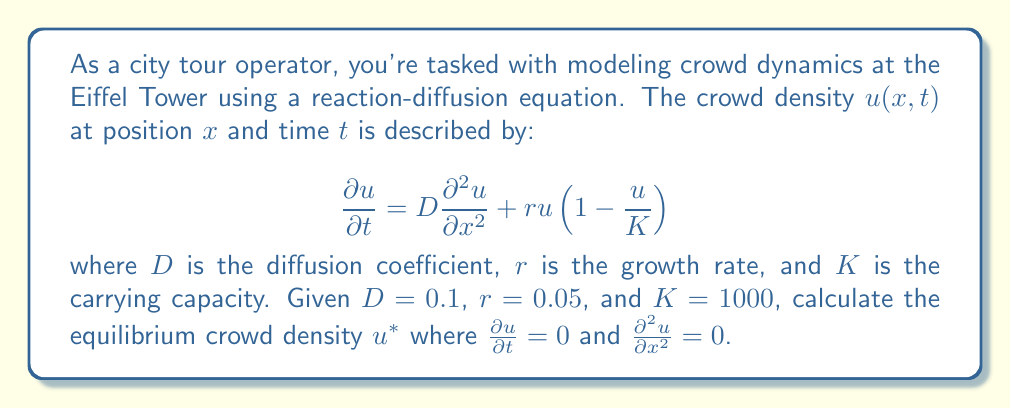Help me with this question. To solve this problem, we need to follow these steps:

1) The equilibrium condition is reached when there's no change in crowd density over time and space. This means:

   $$\frac{\partial u}{\partial t} = 0$$ and $$\frac{\partial^2 u}{\partial x^2} = 0$$

2) Substituting these conditions into the original equation:

   $$0 = D(0) + ru(1-\frac{u}{K})$$

3) Simplify:

   $$0 = ru(1-\frac{u}{K})$$

4) Factor out $u$:

   $$0 = u(r-\frac{ru}{K})$$

5) This equation is satisfied when either $u=0$ or $r-\frac{ru}{K}=0$. The non-trivial solution comes from the second case:

   $$r-\frac{ru}{K}=0$$

6) Solve for $u$:

   $$r = \frac{ru}{K}$$
   $$rK = ru$$
   $$u = K$$

7) Therefore, the equilibrium crowd density $u^*$ is equal to the carrying capacity $K$.

8) Substitute the given value of $K$:

   $$u^* = K = 1000$$

This result indicates that at equilibrium, the crowd density reaches the maximum capacity of the area, which makes sense in the context of a popular landmark like the Eiffel Tower.
Answer: $u^* = 1000$ 